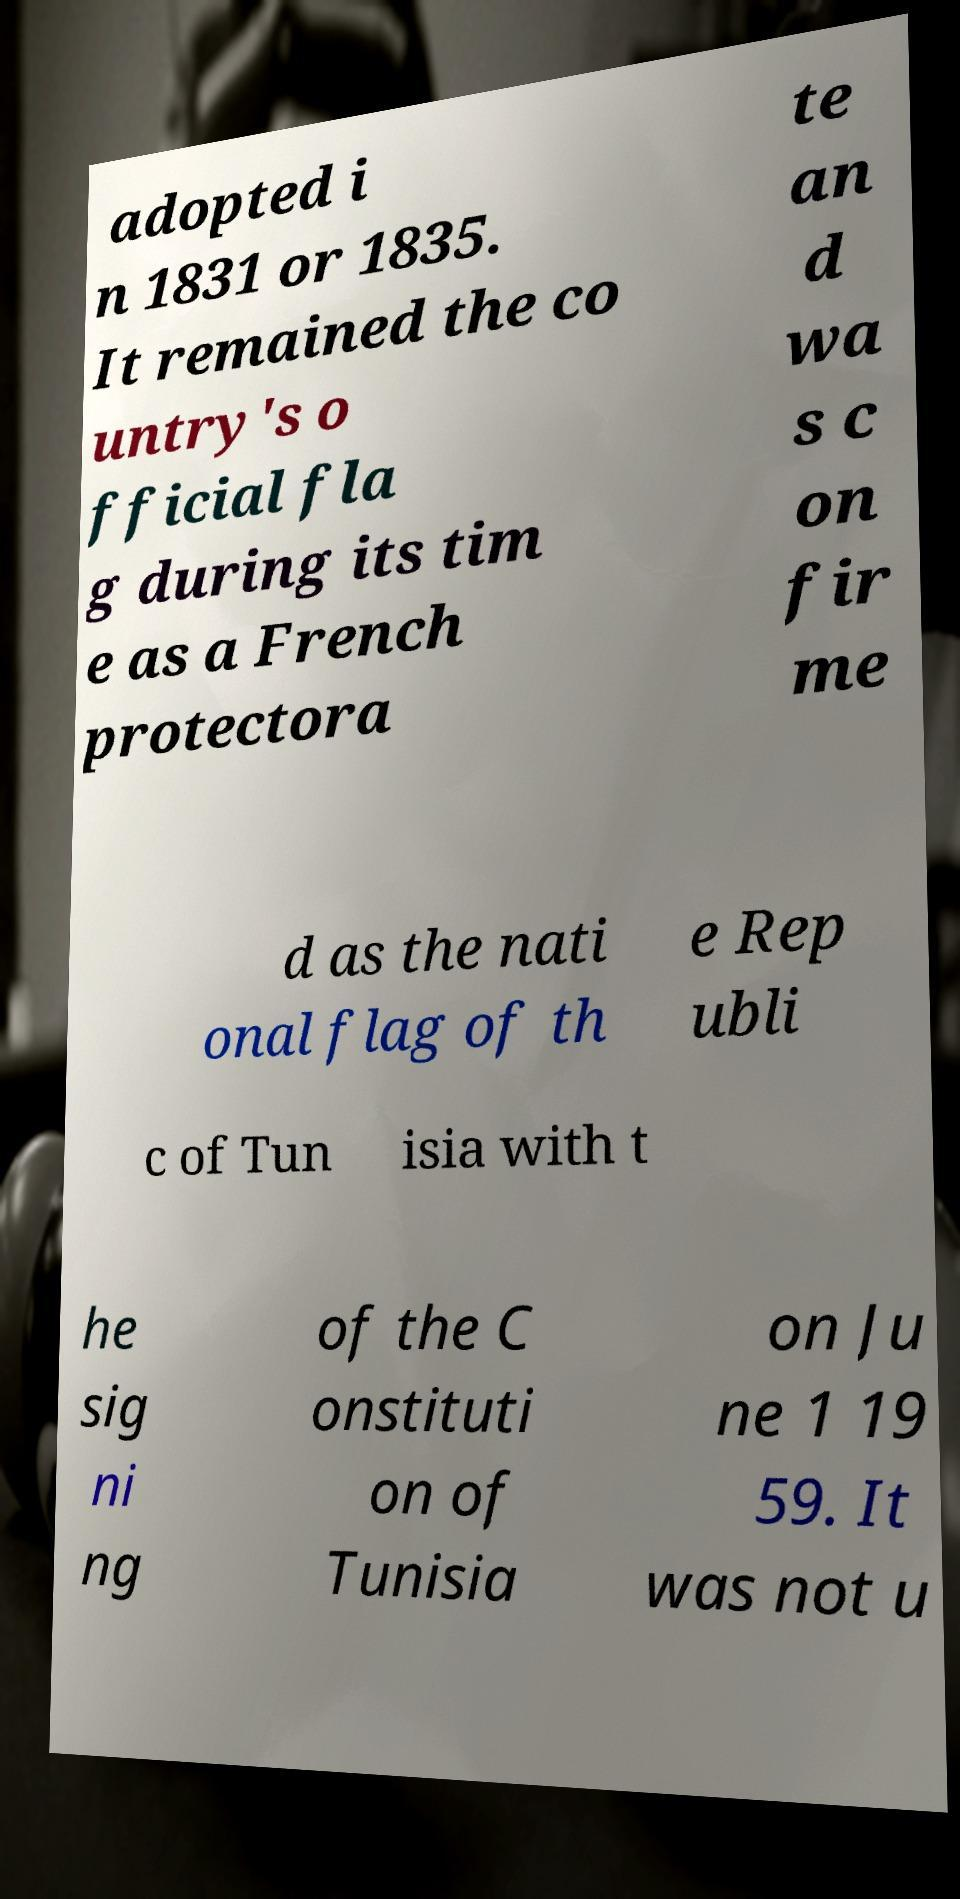Please identify and transcribe the text found in this image. adopted i n 1831 or 1835. It remained the co untry's o fficial fla g during its tim e as a French protectora te an d wa s c on fir me d as the nati onal flag of th e Rep ubli c of Tun isia with t he sig ni ng of the C onstituti on of Tunisia on Ju ne 1 19 59. It was not u 